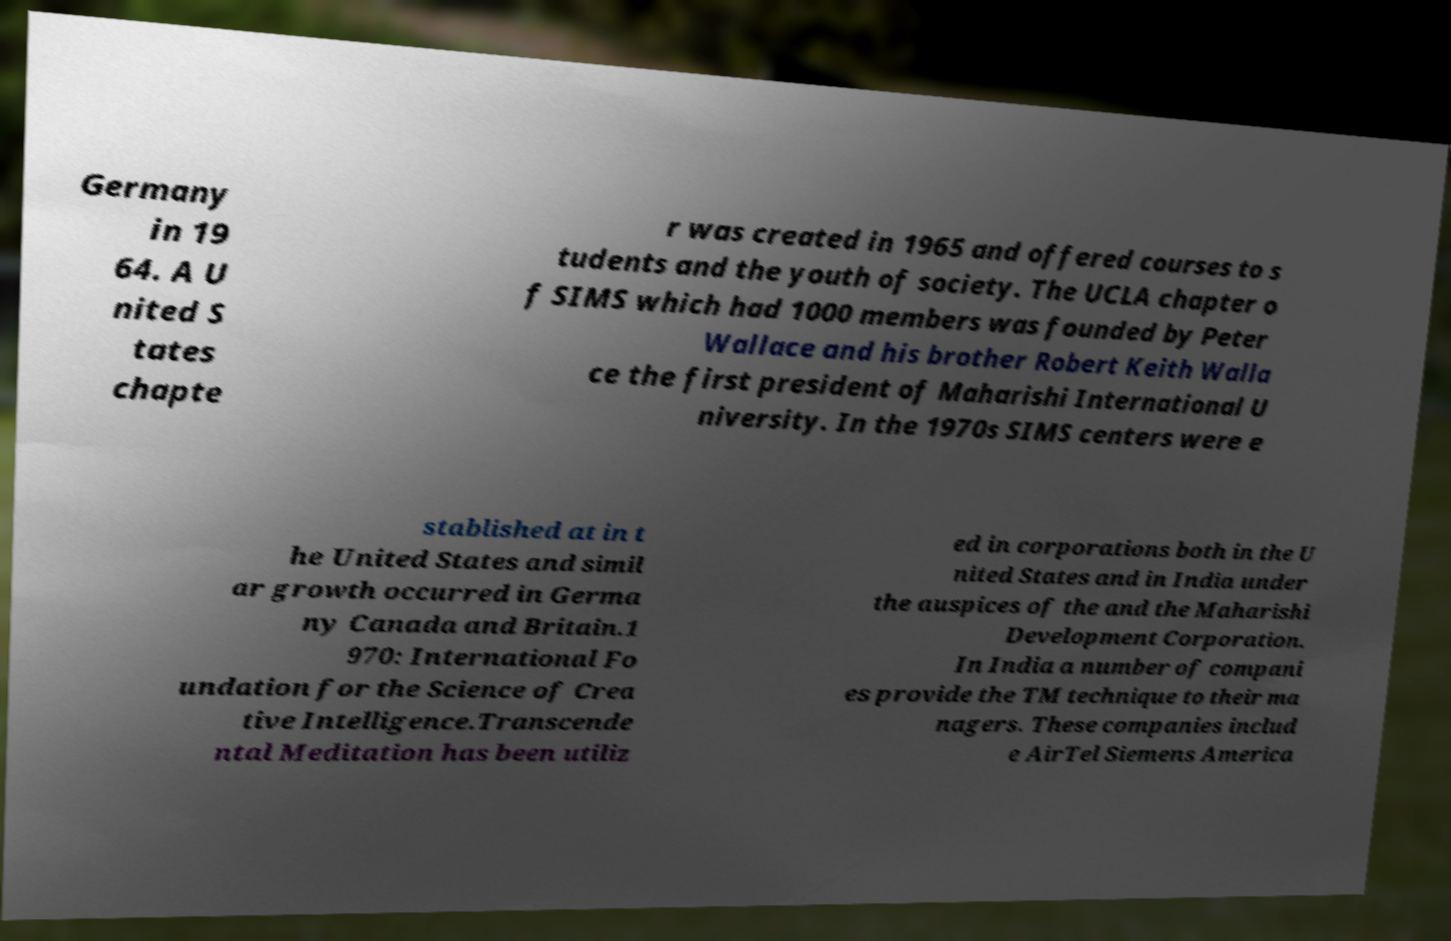What messages or text are displayed in this image? I need them in a readable, typed format. Germany in 19 64. A U nited S tates chapte r was created in 1965 and offered courses to s tudents and the youth of society. The UCLA chapter o f SIMS which had 1000 members was founded by Peter Wallace and his brother Robert Keith Walla ce the first president of Maharishi International U niversity. In the 1970s SIMS centers were e stablished at in t he United States and simil ar growth occurred in Germa ny Canada and Britain.1 970: International Fo undation for the Science of Crea tive Intelligence.Transcende ntal Meditation has been utiliz ed in corporations both in the U nited States and in India under the auspices of the and the Maharishi Development Corporation. In India a number of compani es provide the TM technique to their ma nagers. These companies includ e AirTel Siemens America 